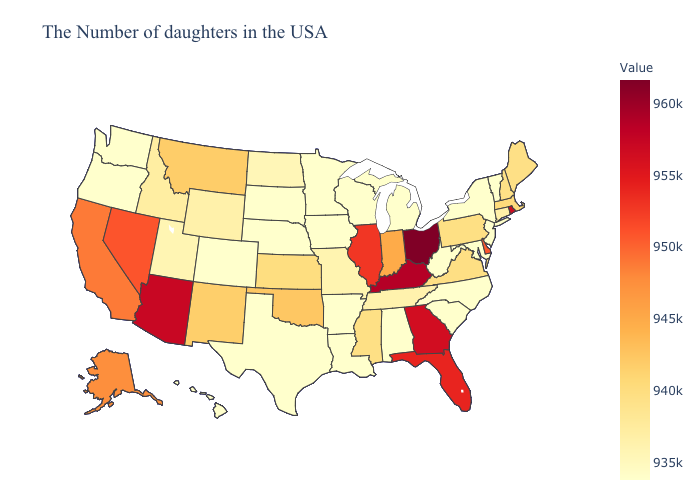Does Ohio have the highest value in the USA?
Answer briefly. Yes. Does the map have missing data?
Give a very brief answer. No. Does North Carolina have the lowest value in the USA?
Be succinct. Yes. Does Ohio have the highest value in the USA?
Short answer required. Yes. 